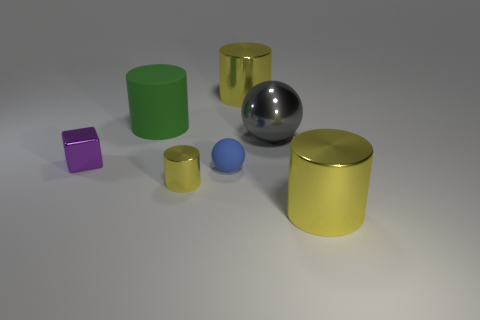Is the size of the gray sphere the same as the yellow metal cylinder that is behind the blue thing?
Keep it short and to the point. Yes. What color is the metallic cylinder that is the same size as the purple object?
Ensure brevity in your answer.  Yellow. The green cylinder has what size?
Offer a terse response. Large. Is the material of the yellow object on the left side of the tiny rubber object the same as the purple thing?
Provide a succinct answer. Yes. Do the purple thing and the large gray thing have the same shape?
Offer a very short reply. No. What shape is the yellow metallic thing that is right of the big metal cylinder that is behind the big green rubber thing behind the small purple metallic thing?
Give a very brief answer. Cylinder. There is a yellow metal thing right of the big gray sphere; is it the same shape as the small yellow metal thing to the left of the big gray ball?
Provide a succinct answer. Yes. Are there any large gray balls made of the same material as the tiny yellow cylinder?
Offer a terse response. Yes. The big thing on the left side of the rubber thing on the right side of the tiny shiny object in front of the tiny blue matte sphere is what color?
Ensure brevity in your answer.  Green. Is the material of the large yellow cylinder in front of the big green thing the same as the yellow thing that is behind the green thing?
Your response must be concise. Yes. 